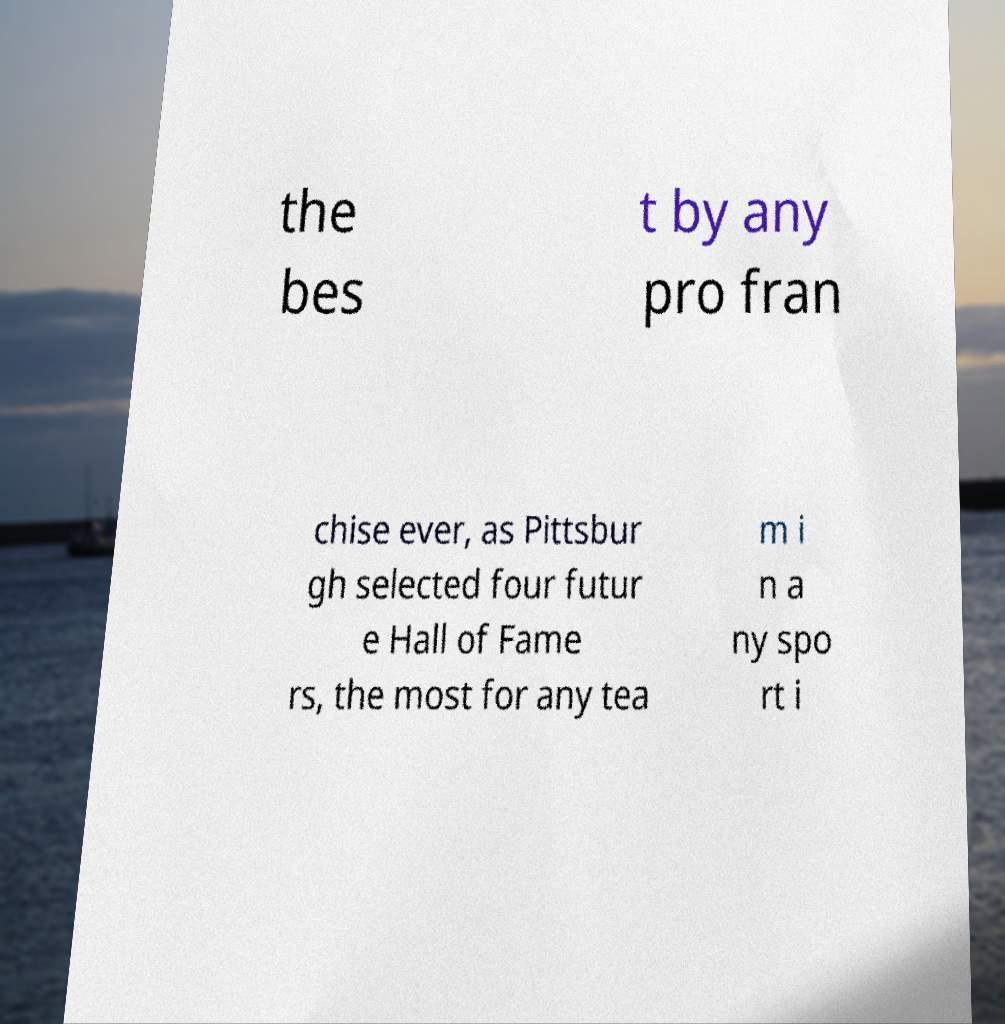Can you accurately transcribe the text from the provided image for me? the bes t by any pro fran chise ever, as Pittsbur gh selected four futur e Hall of Fame rs, the most for any tea m i n a ny spo rt i 